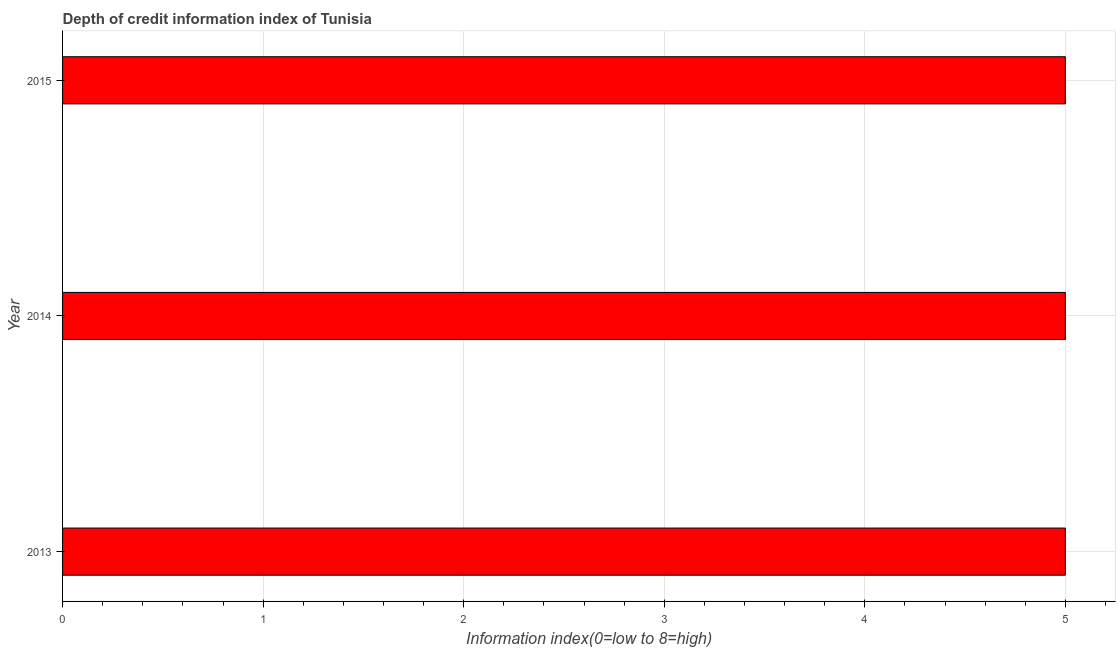Does the graph contain grids?
Offer a terse response. Yes. What is the title of the graph?
Ensure brevity in your answer.  Depth of credit information index of Tunisia. What is the label or title of the X-axis?
Offer a terse response. Information index(0=low to 8=high). What is the label or title of the Y-axis?
Ensure brevity in your answer.  Year. What is the depth of credit information index in 2014?
Keep it short and to the point. 5. Across all years, what is the minimum depth of credit information index?
Make the answer very short. 5. What is the sum of the depth of credit information index?
Give a very brief answer. 15. What is the median depth of credit information index?
Offer a very short reply. 5. In how many years, is the depth of credit information index greater than 4.8 ?
Provide a short and direct response. 3. Do a majority of the years between 2015 and 2013 (inclusive) have depth of credit information index greater than 2 ?
Provide a short and direct response. Yes. Is the difference between the depth of credit information index in 2014 and 2015 greater than the difference between any two years?
Your answer should be compact. Yes. In how many years, is the depth of credit information index greater than the average depth of credit information index taken over all years?
Your answer should be compact. 0. Are all the bars in the graph horizontal?
Provide a short and direct response. Yes. What is the difference between two consecutive major ticks on the X-axis?
Make the answer very short. 1. Are the values on the major ticks of X-axis written in scientific E-notation?
Provide a short and direct response. No. What is the Information index(0=low to 8=high) in 2013?
Offer a terse response. 5. What is the difference between the Information index(0=low to 8=high) in 2013 and 2015?
Your answer should be compact. 0. What is the ratio of the Information index(0=low to 8=high) in 2013 to that in 2015?
Keep it short and to the point. 1. 